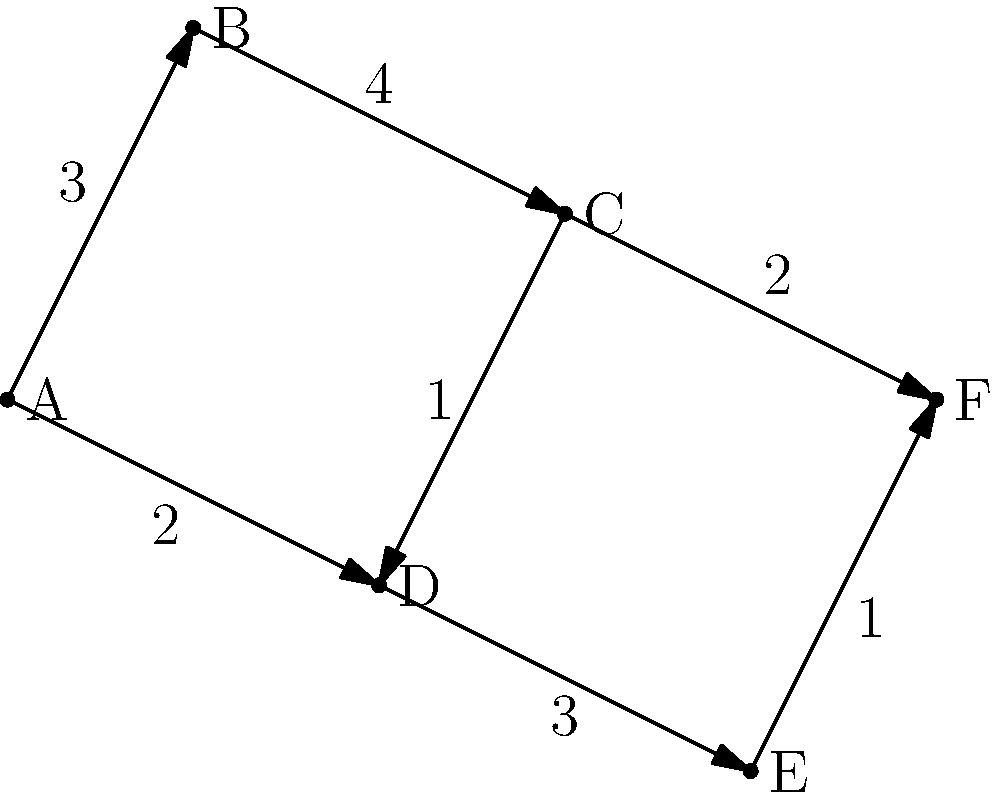In a city network, hospitals are represented by nodes, and the roads connecting them are represented by edges. The numbers on the edges indicate the travel time in minutes between hospitals. As a doctor in training, you need to find the shortest path from Hospital A to Hospital F. What is the minimum time required to travel from Hospital A to Hospital F? To find the shortest path from Hospital A to Hospital F, we'll use Dijkstra's algorithm:

1. Initialize:
   - Distance to A: 0
   - Distance to all other nodes: infinity
   - Set of unvisited nodes: {A, B, C, D, E, F}

2. From A:
   - Update B: min(∞, 0 + 3) = 3
   - Update D: min(∞, 0 + 2) = 2
   - Mark A as visited

3. From D (closest unvisited):
   - Update C: min(∞, 2 + 1) = 3
   - Update E: min(∞, 2 + 3) = 5
   - Mark D as visited

4. From B and C (tied, choose B arbitrarily):
   - Update C: min(3, 3 + 4) = 3 (no change)
   - Mark B as visited

5. From C:
   - Update F: min(∞, 3 + 2) = 5
   - Mark C as visited

6. From E:
   - Update F: min(5, 5 + 1) = 5 (no change)
   - Mark E as visited

7. F is the only unvisited node left, so we're done.

The shortest path from A to F is A → D → C → F, with a total time of 2 + 1 + 2 = 5 minutes.
Answer: 5 minutes 